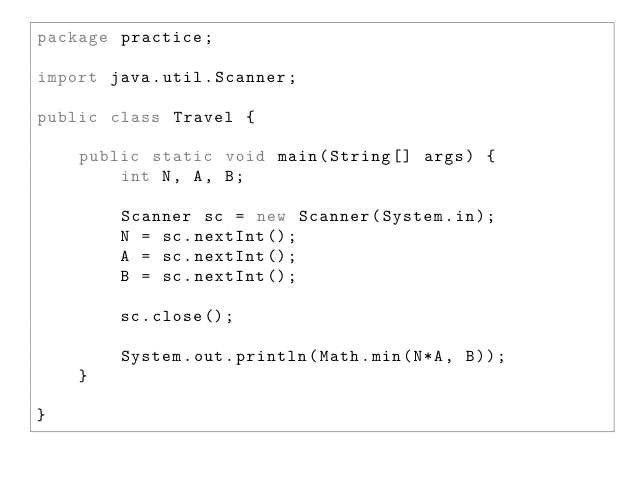<code> <loc_0><loc_0><loc_500><loc_500><_Java_>package practice;

import java.util.Scanner;

public class Travel {

	public static void main(String[] args) {
		int N, A, B;

		Scanner sc = new Scanner(System.in);
		N = sc.nextInt();
		A = sc.nextInt();
		B = sc.nextInt();

		sc.close();

		System.out.println(Math.min(N*A, B));
	}

}</code> 